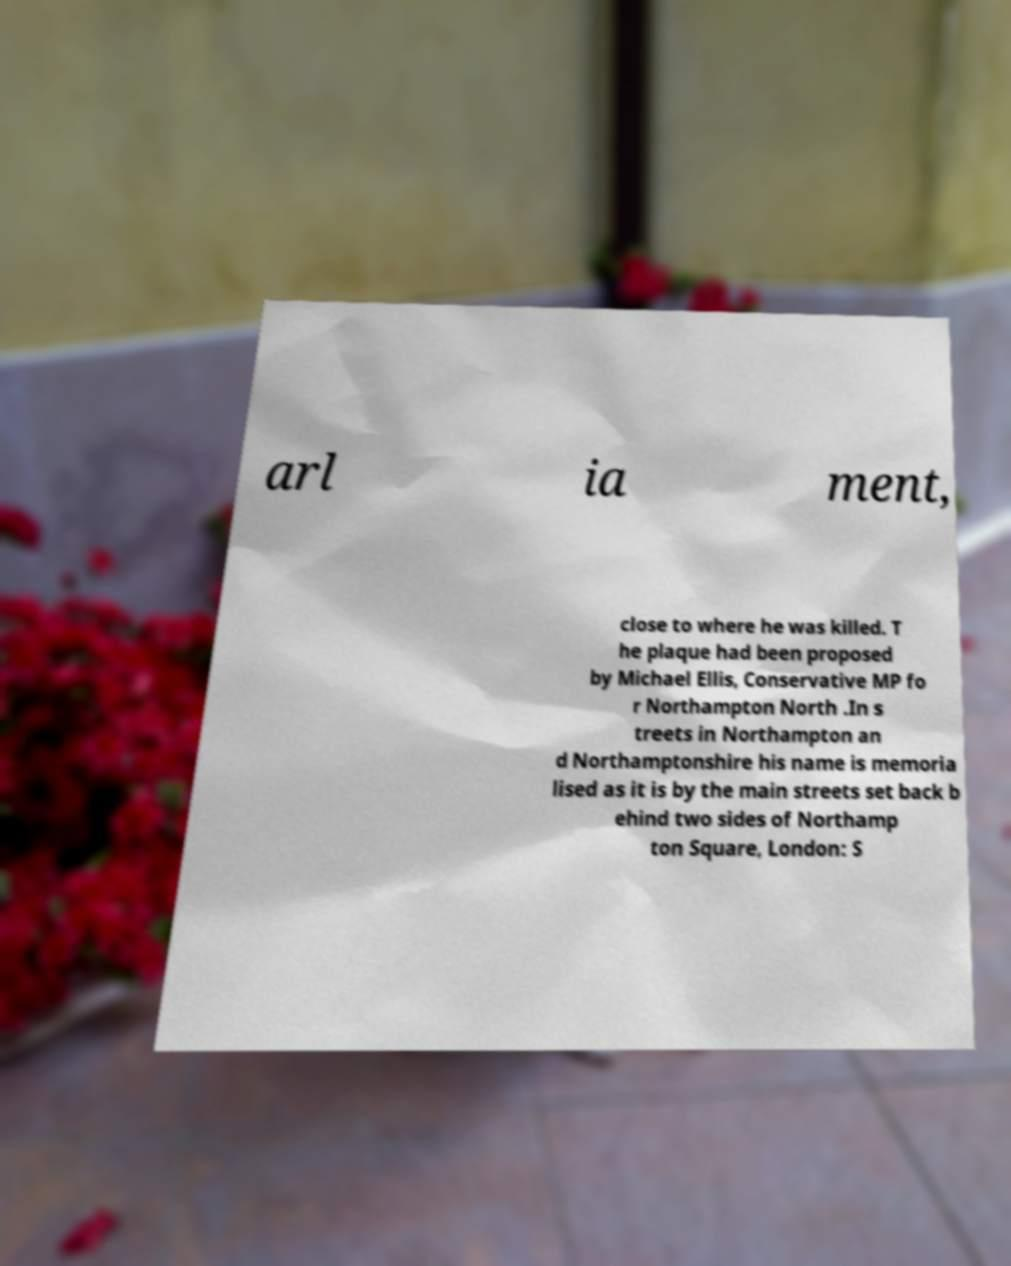What messages or text are displayed in this image? I need them in a readable, typed format. arl ia ment, close to where he was killed. T he plaque had been proposed by Michael Ellis, Conservative MP fo r Northampton North .In s treets in Northampton an d Northamptonshire his name is memoria lised as it is by the main streets set back b ehind two sides of Northamp ton Square, London: S 